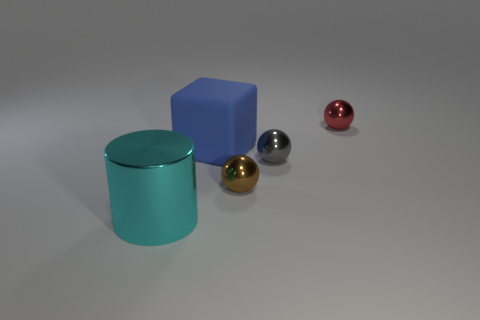There is a ball that is on the right side of the small brown sphere and in front of the blue cube; what size is it?
Provide a short and direct response. Small. Do the large object behind the cyan cylinder and the thing that is behind the big blue rubber block have the same shape?
Give a very brief answer. No. What number of red balls are the same material as the small gray thing?
Your answer should be compact. 1. What is the shape of the shiny thing that is to the right of the tiny brown thing and left of the tiny red ball?
Your response must be concise. Sphere. Is the large object that is behind the cylinder made of the same material as the small red sphere?
Your answer should be compact. No. Is there any other thing that is the same material as the red sphere?
Make the answer very short. Yes. There is another rubber thing that is the same size as the cyan thing; what color is it?
Offer a very short reply. Blue. There is a gray object that is made of the same material as the cylinder; what is its size?
Provide a succinct answer. Small. How many other things are the same size as the brown metallic thing?
Keep it short and to the point. 2. What is the material of the large object to the right of the cyan object?
Offer a terse response. Rubber. 